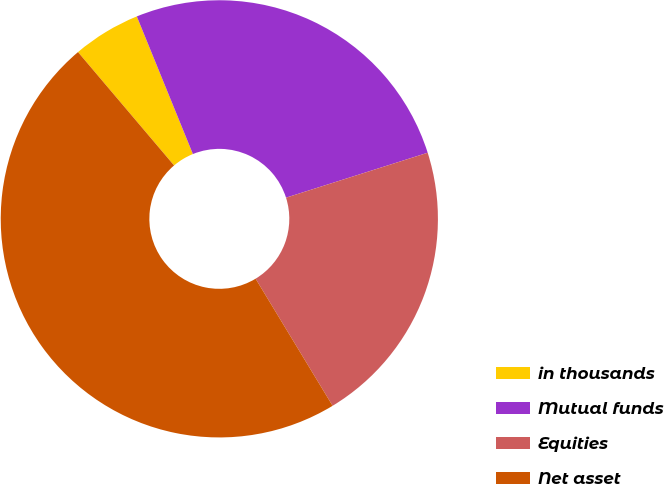<chart> <loc_0><loc_0><loc_500><loc_500><pie_chart><fcel>in thousands<fcel>Mutual funds<fcel>Equities<fcel>Net asset<nl><fcel>5.03%<fcel>26.27%<fcel>21.22%<fcel>47.48%<nl></chart> 